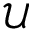Convert formula to latex. <formula><loc_0><loc_0><loc_500><loc_500>\mathcal { U }</formula> 